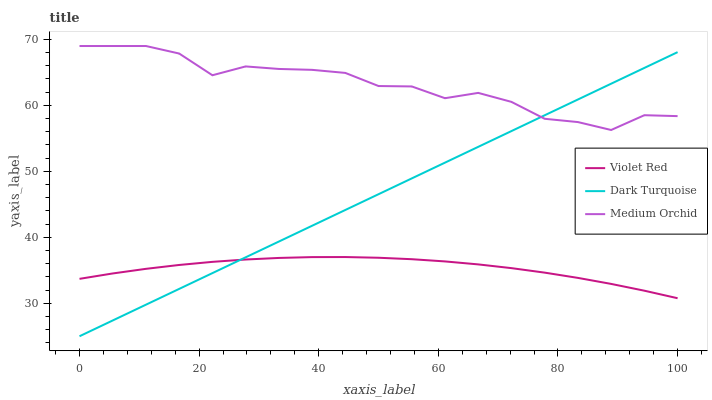Does Medium Orchid have the minimum area under the curve?
Answer yes or no. No. Does Violet Red have the maximum area under the curve?
Answer yes or no. No. Is Violet Red the smoothest?
Answer yes or no. No. Is Violet Red the roughest?
Answer yes or no. No. Does Violet Red have the lowest value?
Answer yes or no. No. Does Violet Red have the highest value?
Answer yes or no. No. Is Violet Red less than Medium Orchid?
Answer yes or no. Yes. Is Medium Orchid greater than Violet Red?
Answer yes or no. Yes. Does Violet Red intersect Medium Orchid?
Answer yes or no. No. 